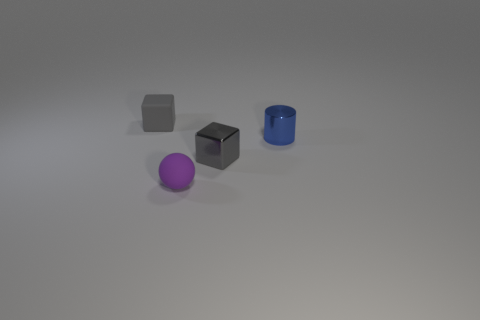Are there any gray blocks that have the same material as the blue object?
Provide a succinct answer. Yes. The tiny gray thing right of the thing to the left of the tiny purple rubber ball is made of what material?
Make the answer very short. Metal. How big is the block that is in front of the tiny metal cylinder?
Keep it short and to the point. Small. There is a cylinder; does it have the same color as the tiny cube right of the small rubber block?
Provide a succinct answer. No. Are there any rubber spheres that have the same color as the small matte cube?
Offer a terse response. No. Does the tiny ball have the same material as the block that is left of the small purple rubber thing?
Ensure brevity in your answer.  Yes. What number of big objects are either purple rubber things or cylinders?
Give a very brief answer. 0. There is another cube that is the same color as the shiny cube; what material is it?
Provide a succinct answer. Rubber. Are there fewer tiny red metal objects than blue metallic things?
Provide a short and direct response. Yes. There is a thing that is to the right of the tiny gray metal cube; is it the same size as the object that is behind the tiny cylinder?
Offer a very short reply. Yes. 